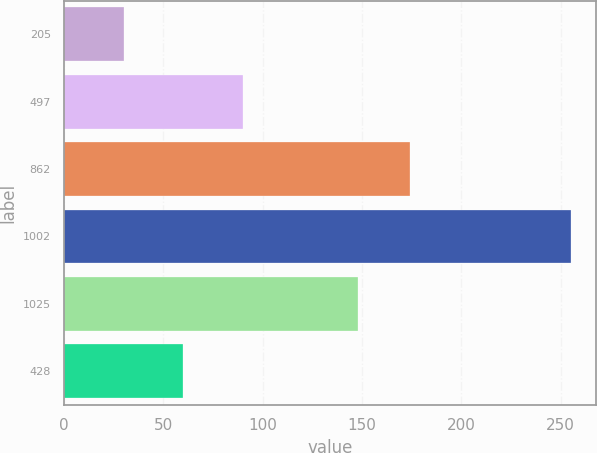Convert chart to OTSL. <chart><loc_0><loc_0><loc_500><loc_500><bar_chart><fcel>205<fcel>497<fcel>862<fcel>1002<fcel>1025<fcel>428<nl><fcel>30<fcel>90<fcel>174<fcel>255<fcel>148<fcel>60<nl></chart> 